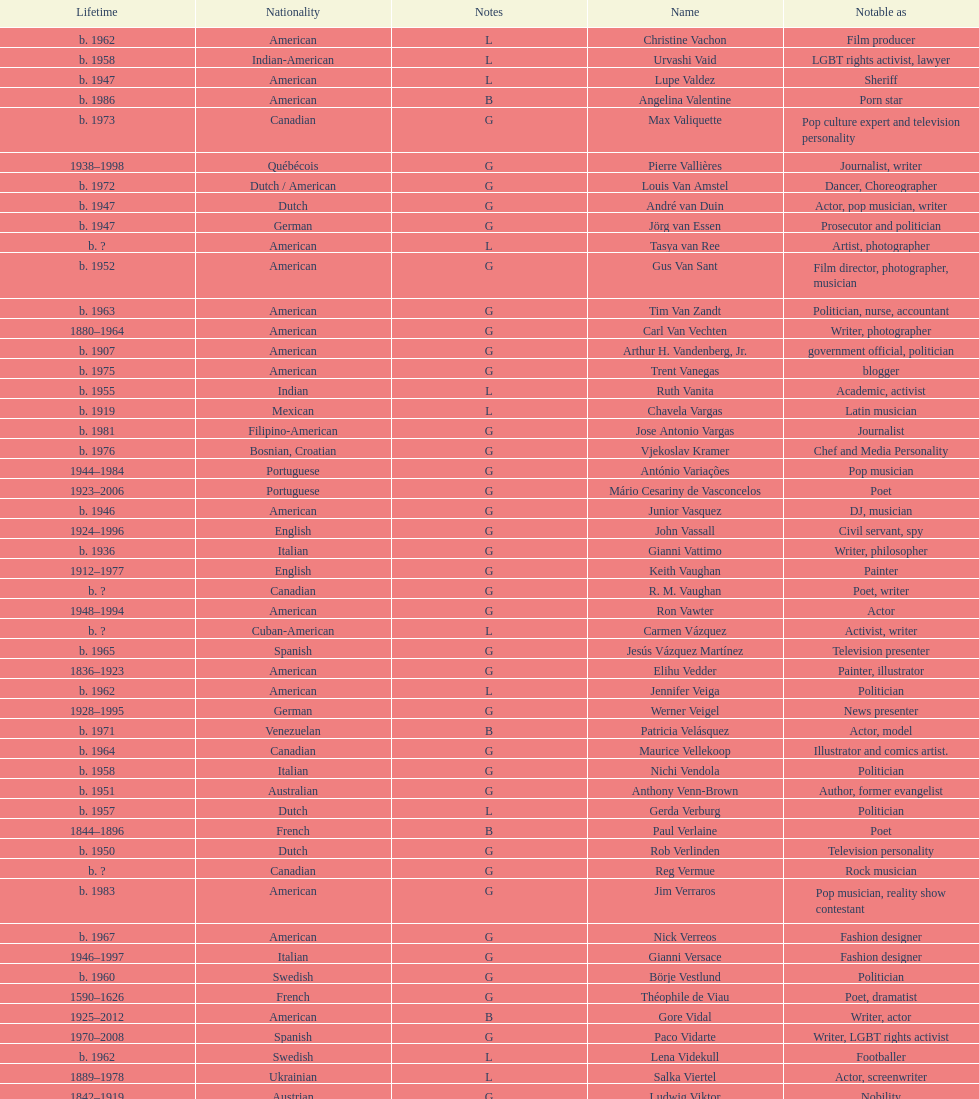Could you parse the entire table as a dict? {'header': ['Lifetime', 'Nationality', 'Notes', 'Name', 'Notable as'], 'rows': [['b. 1962', 'American', 'L', 'Christine Vachon', 'Film producer'], ['b. 1958', 'Indian-American', 'L', 'Urvashi Vaid', 'LGBT rights activist, lawyer'], ['b. 1947', 'American', 'L', 'Lupe Valdez', 'Sheriff'], ['b. 1986', 'American', 'B', 'Angelina Valentine', 'Porn star'], ['b. 1973', 'Canadian', 'G', 'Max Valiquette', 'Pop culture expert and television personality'], ['1938–1998', 'Québécois', 'G', 'Pierre Vallières', 'Journalist, writer'], ['b. 1972', 'Dutch / American', 'G', 'Louis Van Amstel', 'Dancer, Choreographer'], ['b. 1947', 'Dutch', 'G', 'André van Duin', 'Actor, pop musician, writer'], ['b. 1947', 'German', 'G', 'Jörg van Essen', 'Prosecutor and politician'], ['b.\xa0?', 'American', 'L', 'Tasya van Ree', 'Artist, photographer'], ['b. 1952', 'American', 'G', 'Gus Van Sant', 'Film director, photographer, musician'], ['b. 1963', 'American', 'G', 'Tim Van Zandt', 'Politician, nurse, accountant'], ['1880–1964', 'American', 'G', 'Carl Van Vechten', 'Writer, photographer'], ['b. 1907', 'American', 'G', 'Arthur H. Vandenberg, Jr.', 'government official, politician'], ['b. 1975', 'American', 'G', 'Trent Vanegas', 'blogger'], ['b. 1955', 'Indian', 'L', 'Ruth Vanita', 'Academic, activist'], ['b. 1919', 'Mexican', 'L', 'Chavela Vargas', 'Latin musician'], ['b. 1981', 'Filipino-American', 'G', 'Jose Antonio Vargas', 'Journalist'], ['b. 1976', 'Bosnian, Croatian', 'G', 'Vjekoslav Kramer', 'Chef and Media Personality'], ['1944–1984', 'Portuguese', 'G', 'António Variações', 'Pop musician'], ['1923–2006', 'Portuguese', 'G', 'Mário Cesariny de Vasconcelos', 'Poet'], ['b. 1946', 'American', 'G', 'Junior Vasquez', 'DJ, musician'], ['1924–1996', 'English', 'G', 'John Vassall', 'Civil servant, spy'], ['b. 1936', 'Italian', 'G', 'Gianni Vattimo', 'Writer, philosopher'], ['1912–1977', 'English', 'G', 'Keith Vaughan', 'Painter'], ['b.\xa0?', 'Canadian', 'G', 'R. M. Vaughan', 'Poet, writer'], ['1948–1994', 'American', 'G', 'Ron Vawter', 'Actor'], ['b.\xa0?', 'Cuban-American', 'L', 'Carmen Vázquez', 'Activist, writer'], ['b. 1965', 'Spanish', 'G', 'Jesús Vázquez Martínez', 'Television presenter'], ['1836–1923', 'American', 'G', 'Elihu Vedder', 'Painter, illustrator'], ['b. 1962', 'American', 'L', 'Jennifer Veiga', 'Politician'], ['1928–1995', 'German', 'G', 'Werner Veigel', 'News presenter'], ['b. 1971', 'Venezuelan', 'B', 'Patricia Velásquez', 'Actor, model'], ['b. 1964', 'Canadian', 'G', 'Maurice Vellekoop', 'Illustrator and comics artist.'], ['b. 1958', 'Italian', 'G', 'Nichi Vendola', 'Politician'], ['b. 1951', 'Australian', 'G', 'Anthony Venn-Brown', 'Author, former evangelist'], ['b. 1957', 'Dutch', 'L', 'Gerda Verburg', 'Politician'], ['1844–1896', 'French', 'B', 'Paul Verlaine', 'Poet'], ['b. 1950', 'Dutch', 'G', 'Rob Verlinden', 'Television personality'], ['b.\xa0?', 'Canadian', 'G', 'Reg Vermue', 'Rock musician'], ['b. 1983', 'American', 'G', 'Jim Verraros', 'Pop musician, reality show contestant'], ['b. 1967', 'American', 'G', 'Nick Verreos', 'Fashion designer'], ['1946–1997', 'Italian', 'G', 'Gianni Versace', 'Fashion designer'], ['b. 1960', 'Swedish', 'G', 'Börje Vestlund', 'Politician'], ['1590–1626', 'French', 'G', 'Théophile de Viau', 'Poet, dramatist'], ['1925–2012', 'American', 'B', 'Gore Vidal', 'Writer, actor'], ['1970–2008', 'Spanish', 'G', 'Paco Vidarte', 'Writer, LGBT rights activist'], ['b. 1962', 'Swedish', 'L', 'Lena Videkull', 'Footballer'], ['1889–1978', 'Ukrainian', 'L', 'Salka Viertel', 'Actor, screenwriter'], ['1842–1919', 'Austrian', 'G', 'Ludwig Viktor', 'Nobility'], ['b. 1948', 'American', 'G', 'Bruce Vilanch', 'Comedy writer, actor'], ['1953–1994', 'American', 'G', 'Tom Villard', 'Actor'], ['b. 1961', 'American', 'G', 'José Villarrubia', 'Artist'], ['1903–1950', 'Mexican', 'G', 'Xavier Villaurrutia', 'Poet, playwright'], ['1950–2000', 'French', 'G', "Alain-Philippe Malagnac d'Argens de Villèle", 'Aristocrat'], ['b.\xa0?', 'American', 'L', 'Norah Vincent', 'Journalist'], ['1917–1998', 'American', 'G', 'Donald Vining', 'Writer'], ['1906–1976', 'Italian', 'G', 'Luchino Visconti', 'Filmmaker'], ['b. 1962', 'Czech', 'G', 'Pavel Vítek', 'Pop musician, actor'], ['1877–1909', 'English', 'L', 'Renée Vivien', 'Poet'], ['1948–1983', 'Canadian', 'G', 'Claude Vivier', '20th century classical composer'], ['b. 1983', 'American', 'B', 'Taylor Vixen', 'Porn star'], ['1934–1994', 'American', 'G', 'Bruce Voeller', 'HIV/AIDS researcher'], ['b. 1951', 'American', 'L', 'Paula Vogel', 'Playwright'], ['b. 1985', 'Russian', 'B', 'Julia Volkova', 'Singer'], ['b. 1947', 'German', 'G', 'Jörg van Essen', 'Politician'], ['b. 1955', 'German', 'G', 'Ole von Beust', 'Politician'], ['1856–1931', 'German', 'G', 'Wilhelm von Gloeden', 'Photographer'], ['b. 1942', 'German', 'G', 'Rosa von Praunheim', 'Film director'], ['b. 1901–1996', 'German', 'G', 'Kurt von Ruffin', 'Holocaust survivor'], ['b. 1959', 'German', 'L', 'Hella von Sinnen', 'Comedian'], ['b. 1981', 'American', 'G', 'Daniel Vosovic', 'Fashion designer'], ['b. 1966', 'Canadian', 'G', 'Delwin Vriend', 'LGBT rights activist']]} What is the number of individuals in this group who were indian? 1. 